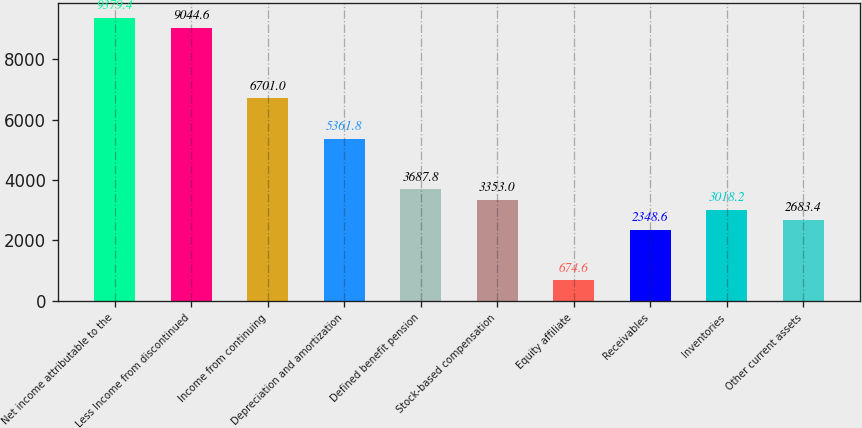<chart> <loc_0><loc_0><loc_500><loc_500><bar_chart><fcel>Net income attributable to the<fcel>Less Income from discontinued<fcel>Income from continuing<fcel>Depreciation and amortization<fcel>Defined benefit pension<fcel>Stock-based compensation<fcel>Equity affiliate<fcel>Receivables<fcel>Inventories<fcel>Other current assets<nl><fcel>9379.4<fcel>9044.6<fcel>6701<fcel>5361.8<fcel>3687.8<fcel>3353<fcel>674.6<fcel>2348.6<fcel>3018.2<fcel>2683.4<nl></chart> 